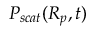Convert formula to latex. <formula><loc_0><loc_0><loc_500><loc_500>P _ { s c a t } ( R _ { p } , t )</formula> 